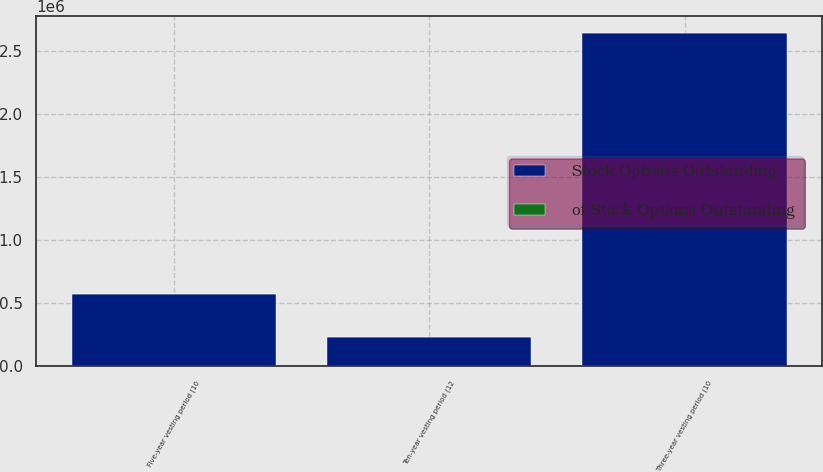<chart> <loc_0><loc_0><loc_500><loc_500><stacked_bar_chart><ecel><fcel>Three-year vesting period (10<fcel>Five-year vesting period (10<fcel>Ten-year vesting period (12<nl><fcel>Stock Options Outstanding<fcel>2.64534e+06<fcel>573793<fcel>232566<nl><fcel>of Stock Options Outstanding<fcel>76.6<fcel>16.7<fcel>6.7<nl></chart> 